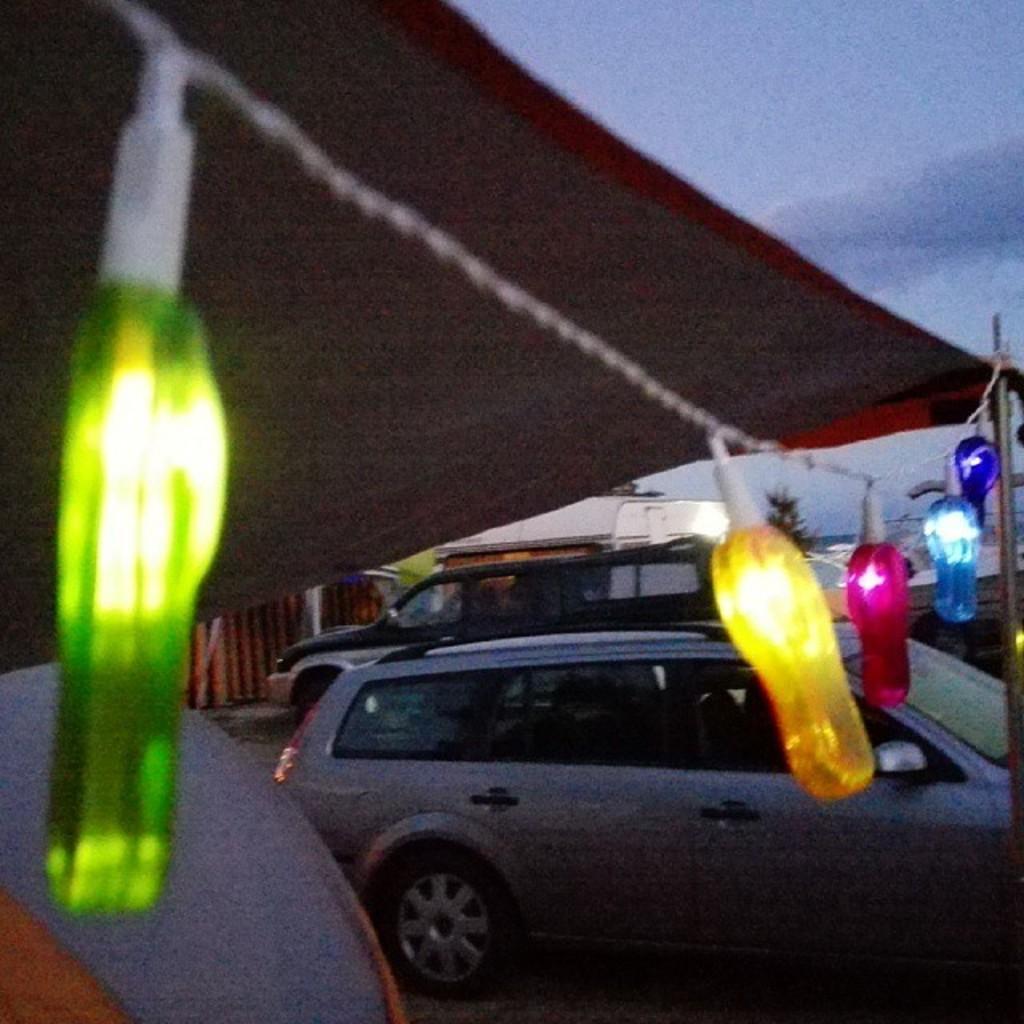Can you describe this image briefly? In this picture we can see some cars and some lights tied to a thread to the poles and the lights are in pink, red, yellow and blue in color. 